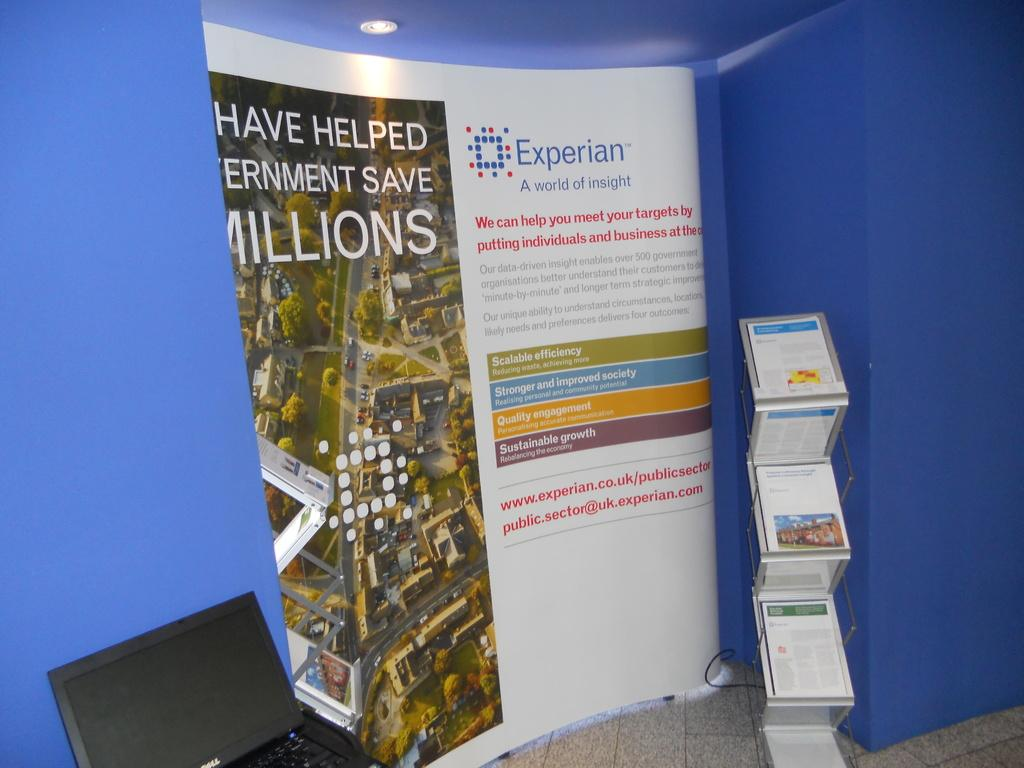<image>
Render a clear and concise summary of the photo. A display for Experian a world of insights and  laptop on the left . 